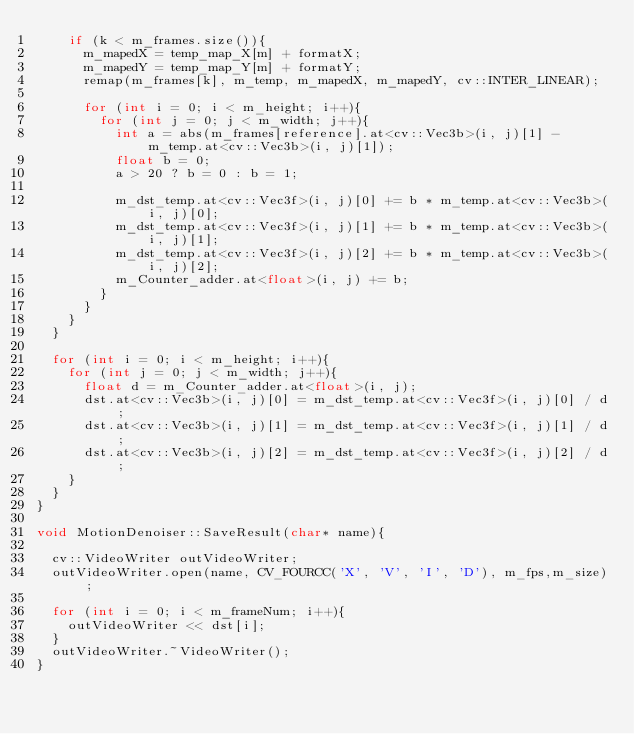Convert code to text. <code><loc_0><loc_0><loc_500><loc_500><_C++_>		if (k < m_frames.size()){
			m_mapedX = temp_map_X[m] + formatX;
			m_mapedY = temp_map_Y[m] + formatY;
			remap(m_frames[k], m_temp, m_mapedX, m_mapedY, cv::INTER_LINEAR);

			for (int i = 0; i < m_height; i++){
				for (int j = 0; j < m_width; j++){
					int a = abs(m_frames[reference].at<cv::Vec3b>(i, j)[1] - m_temp.at<cv::Vec3b>(i, j)[1]);
					float b = 0;
					a > 20 ? b = 0 : b = 1;
					
					m_dst_temp.at<cv::Vec3f>(i, j)[0] += b * m_temp.at<cv::Vec3b>(i, j)[0];
					m_dst_temp.at<cv::Vec3f>(i, j)[1] += b * m_temp.at<cv::Vec3b>(i, j)[1];
					m_dst_temp.at<cv::Vec3f>(i, j)[2] += b * m_temp.at<cv::Vec3b>(i, j)[2];
					m_Counter_adder.at<float>(i, j) += b; 
				}
			}
		}
	}

	for (int i = 0; i < m_height; i++){
		for (int j = 0; j < m_width; j++){
			float d = m_Counter_adder.at<float>(i, j);
			dst.at<cv::Vec3b>(i, j)[0] = m_dst_temp.at<cv::Vec3f>(i, j)[0] / d;
			dst.at<cv::Vec3b>(i, j)[1] = m_dst_temp.at<cv::Vec3f>(i, j)[1] / d;
			dst.at<cv::Vec3b>(i, j)[2] = m_dst_temp.at<cv::Vec3f>(i, j)[2] / d;
		}
	}
}

void MotionDenoiser::SaveResult(char* name){
	
	cv::VideoWriter outVideoWriter;
	outVideoWriter.open(name, CV_FOURCC('X', 'V', 'I', 'D'), m_fps,m_size);
	
	for (int i = 0; i < m_frameNum; i++){
		outVideoWriter << dst[i];
	}
	outVideoWriter.~VideoWriter();
}</code> 